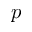<formula> <loc_0><loc_0><loc_500><loc_500>p</formula> 